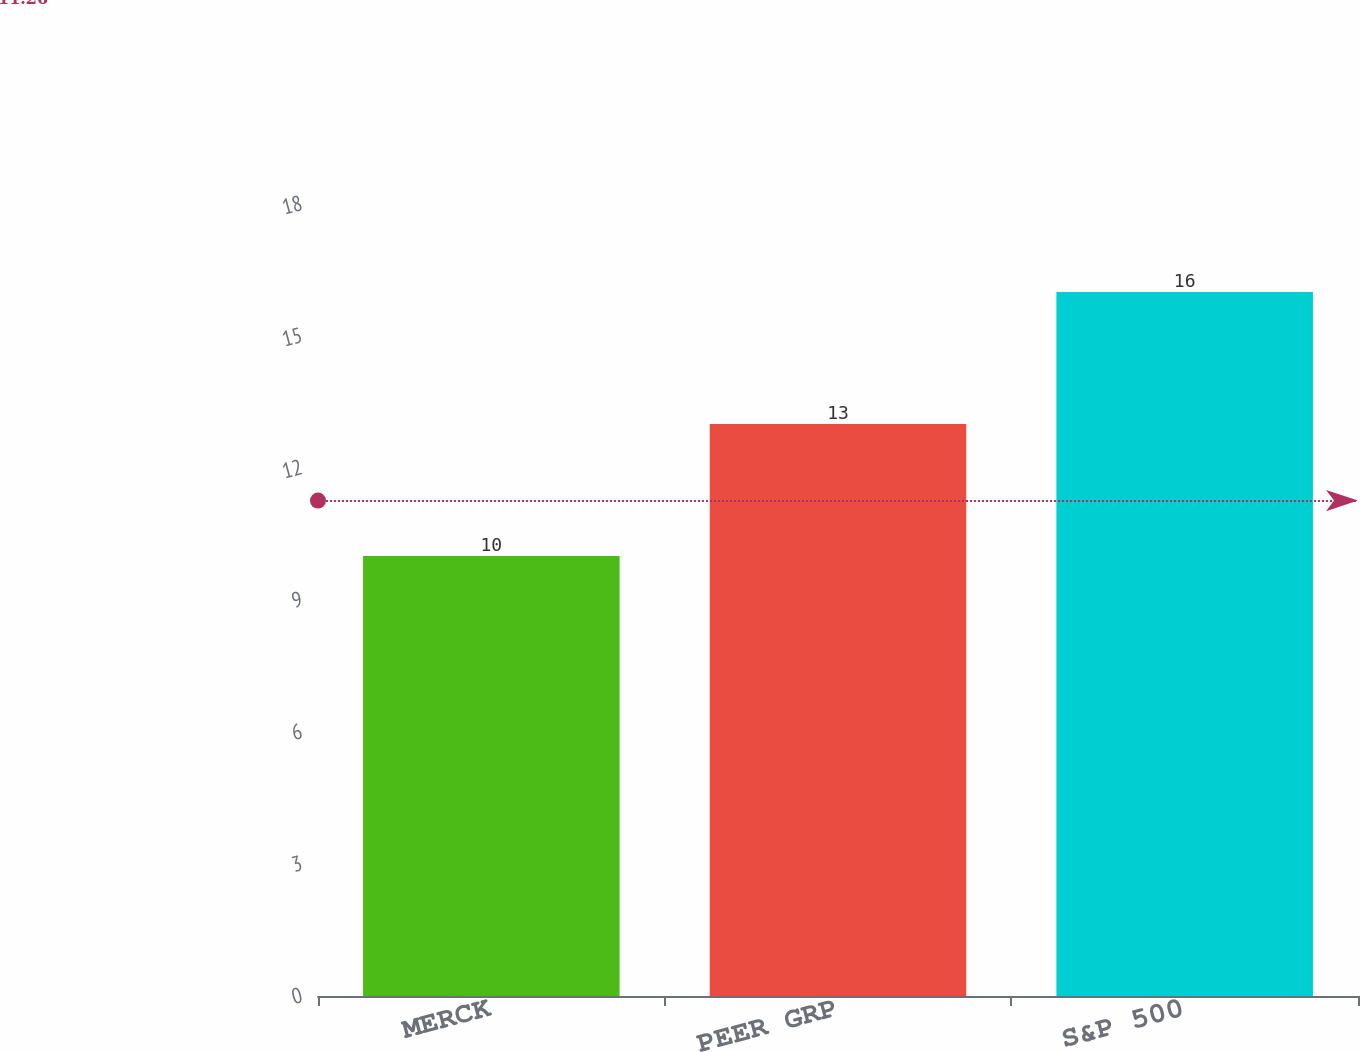Convert chart. <chart><loc_0><loc_0><loc_500><loc_500><bar_chart><fcel>MERCK<fcel>PEER GRP<fcel>S&P 500<nl><fcel>10<fcel>13<fcel>16<nl></chart> 